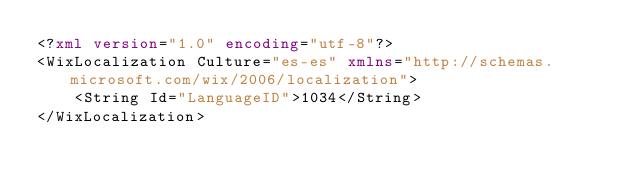Convert code to text. <code><loc_0><loc_0><loc_500><loc_500><_XML_><?xml version="1.0" encoding="utf-8"?>
<WixLocalization Culture="es-es" xmlns="http://schemas.microsoft.com/wix/2006/localization">
	<String Id="LanguageID">1034</String>
</WixLocalization></code> 